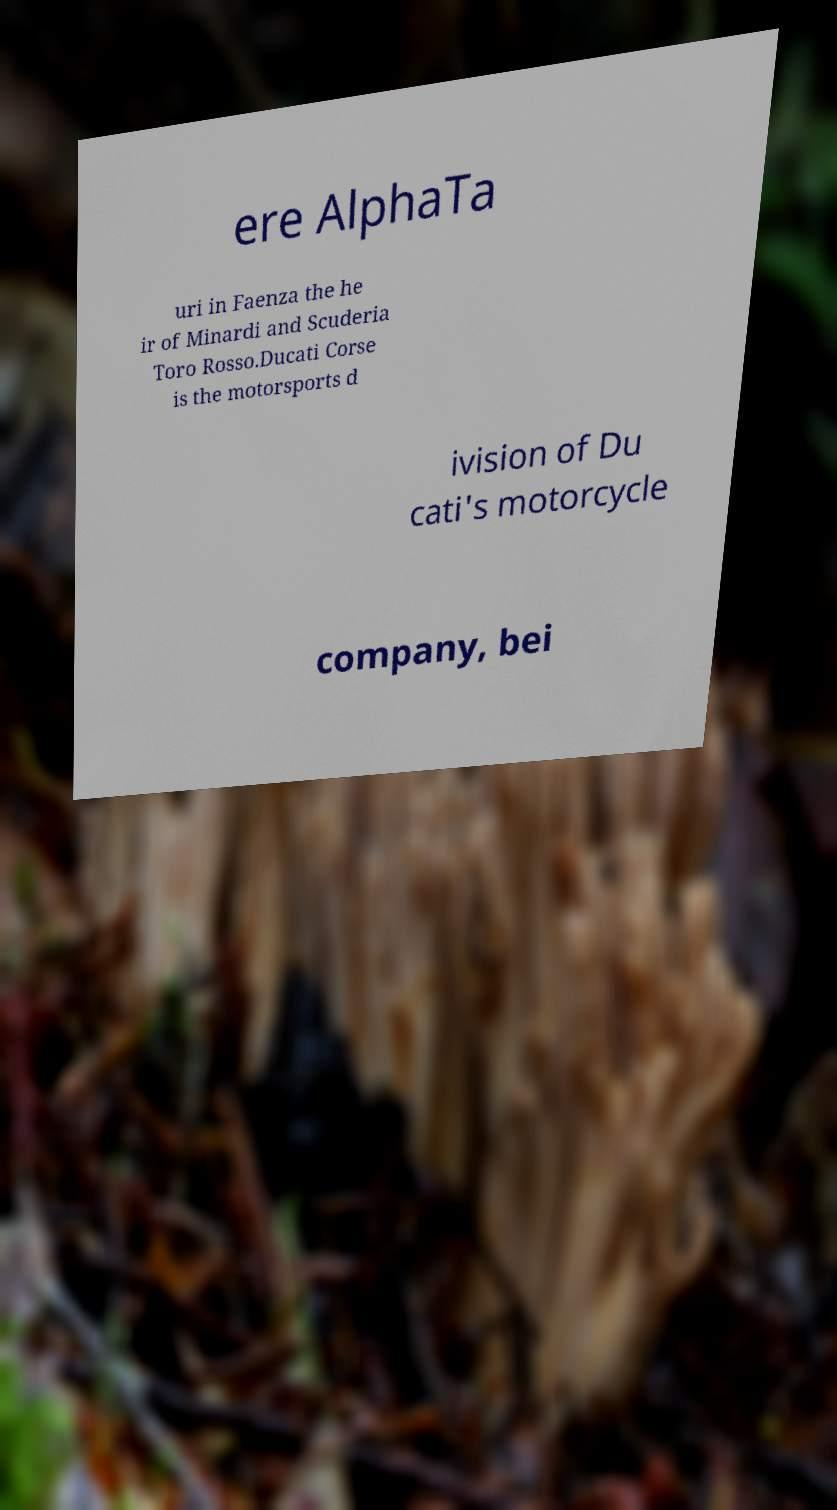There's text embedded in this image that I need extracted. Can you transcribe it verbatim? ere AlphaTa uri in Faenza the he ir of Minardi and Scuderia Toro Rosso.Ducati Corse is the motorsports d ivision of Du cati's motorcycle company, bei 